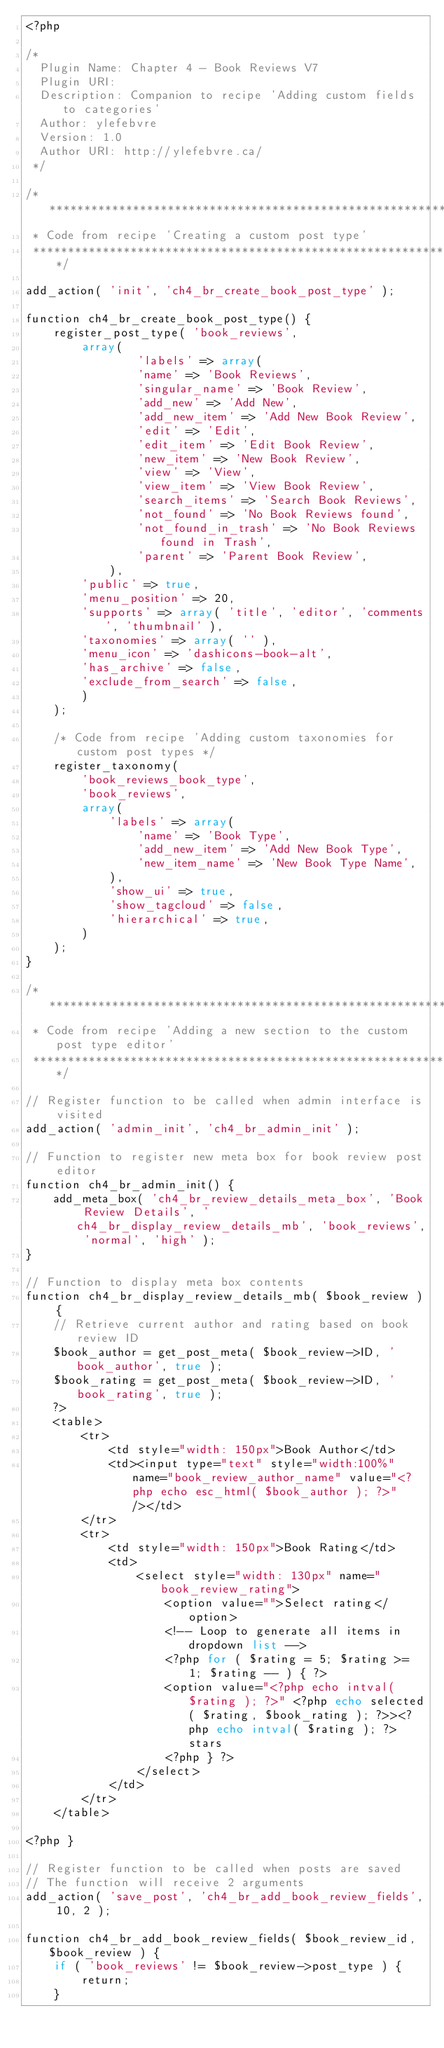<code> <loc_0><loc_0><loc_500><loc_500><_PHP_><?php

/*
  Plugin Name: Chapter 4 - Book Reviews V7
  Plugin URI: 
  Description: Companion to recipe 'Adding custom fields to categories'
  Author: ylefebvre
  Version: 1.0
  Author URI: http://ylefebvre.ca/
 */

/****************************************************************************
 * Code from recipe 'Creating a custom post type'
 ****************************************************************************/

add_action( 'init', 'ch4_br_create_book_post_type' );

function ch4_br_create_book_post_type() {
	register_post_type( 'book_reviews',
		array(
				'labels' => array(
				'name' => 'Book Reviews',
				'singular_name' => 'Book Review',
				'add_new' => 'Add New',
				'add_new_item' => 'Add New Book Review',
				'edit' => 'Edit',
				'edit_item' => 'Edit Book Review',
				'new_item' => 'New Book Review',
				'view' => 'View',
				'view_item' => 'View Book Review',
				'search_items' => 'Search Book Reviews',
				'not_found' => 'No Book Reviews found',
				'not_found_in_trash' => 'No Book Reviews found in Trash',
				'parent' => 'Parent Book Review',
			),
		'public' => true,
		'menu_position' => 20,
		'supports' => array( 'title', 'editor', 'comments', 'thumbnail' ),
		'taxonomies' => array( '' ),
		'menu_icon' => 'dashicons-book-alt',
		'has_archive' => false,
		'exclude_from_search' => false,
		)
	);
	
	/* Code from recipe 'Adding custom taxonomies for custom post types */    
	register_taxonomy(
		'book_reviews_book_type',
		'book_reviews',
		array(
			'labels' => array(
				'name' => 'Book Type',
				'add_new_item' => 'Add New Book Type',
				'new_item_name' => 'New Book Type Name',
			),
			'show_ui' => true,
			'show_tagcloud' => false,
			'hierarchical' => true,
		)
	);
}

/****************************************************************************
 * Code from recipe 'Adding a new section to the custom post type editor'
 ****************************************************************************/

// Register function to be called when admin interface is visited
add_action( 'admin_init', 'ch4_br_admin_init' );

// Function to register new meta box for book review post editor
function ch4_br_admin_init() {
	add_meta_box( 'ch4_br_review_details_meta_box', 'Book Review Details', 'ch4_br_display_review_details_mb', 'book_reviews', 'normal', 'high' );
}

// Function to display meta box contents
function ch4_br_display_review_details_mb( $book_review ) { 
	// Retrieve current author and rating based on book review ID
	$book_author = get_post_meta( $book_review->ID, 'book_author', true );
	$book_rating = get_post_meta( $book_review->ID, 'book_rating', true );
	?>
	<table>
		<tr>
			<td style="width: 150px">Book Author</td>
			<td><input type="text" style="width:100%" name="book_review_author_name" value="<?php echo esc_html( $book_author ); ?>" /></td>
		</tr>
		<tr>
			<td style="width: 150px">Book Rating</td>
			<td>
				<select style="width: 130px" name="book_review_rating">
					<option value="">Select rating</option>
					<!-- Loop to generate all items in dropdown list -->
					<?php for ( $rating = 5; $rating >= 1; $rating -- ) { ?>
					<option value="<?php echo intval( $rating ); ?>" <?php echo selected( $rating, $book_rating ); ?>><?php echo intval( $rating ); ?> stars
					<?php } ?>
				</select>
			</td>
		</tr>
	</table>

<?php }

// Register function to be called when posts are saved
// The function will receive 2 arguments
add_action( 'save_post', 'ch4_br_add_book_review_fields', 10, 2 );

function ch4_br_add_book_review_fields( $book_review_id, $book_review ) {
	if ( 'book_reviews' != $book_review->post_type ) {
		return;
	}
</code> 